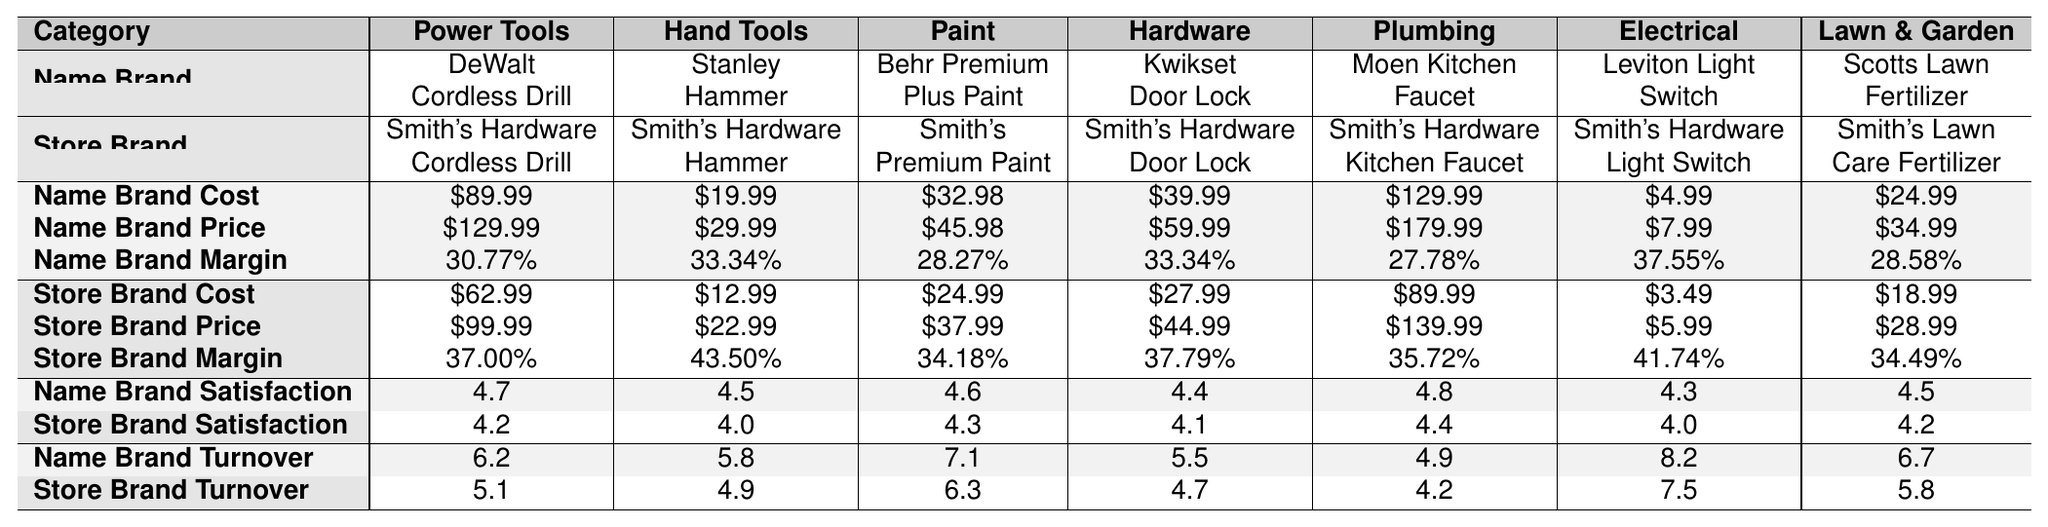What is the highest profit margin among the name-brand products? Look at the profit margin values for the name-brand products and identify the maximum. The values are 30.77%, 33.34%, 28.27%, 33.34%, 27.78%, 37.55%, and 28.58%. The highest is 37.55%.
Answer: 37.55% Which store-brand product has the lowest customer satisfaction rating? The ratings for store-brand products are 4.2, 4.0, 4.3, 4.1, 4.4, 4.0, and 4.2. The lowest rating is 4.0 for both the store-brand hammer and the light switch.
Answer: 4.0 What is the average profit margin for store-brand products? Sum the profit margins for store-brand products: 37.00% + 43.50% + 34.18% + 37.79% + 35.72% + 41.74% + 34.49% = 264.42%. Divide by the number of products (7): 264.42% / 7 = 37.77%.
Answer: 37.77% Are name-brand products generally associated with higher customer satisfaction than store-brand products? Comparing the average customer satisfaction ratings, name-brand products have an average of (4.7 + 4.5 + 4.6 + 4.4 + 4.8 + 4.3 + 4.5) / 7 = 4.57, while store-brand products average (4.2 + 4.0 + 4.3 + 4.1 + 4.4 + 4.0 + 4.2) / 7 = 4.19. Since 4.57 > 4.19, name-brand products have higher satisfaction.
Answer: Yes What is the difference in profit margins between the name-brand and store-brand paint products? The profit margins for name-brand paint is 28.27%, and for store-brand paint, it is 34.18%. Calculate the difference: 34.18% - 28.27% = 5.91%.
Answer: 5.91% Which product category shows the greatest difference in cost between name-brand and store-brand products? Calculate the cost difference for each category: Power Tools: 89.99 - 62.99 = 27.00, Hand Tools: 19.99 - 12.99 = 7.00, Paint: 32.98 - 24.99 = 7.99, Hardware: 39.99 - 27.99 = 12.00, Plumbing: 129.99 - 89.99 = 40.00, Electrical: 4.99 - 3.49 = 1.50, Lawn & Garden: 24.99 - 18.99 = 6.00. The greatest difference is 40.00 in the Plumbing category.
Answer: 40.00 What is the total inventory turnover for name-brand products? Sum the inventory turnover values for name-brand products: 6.2 + 5.8 + 7.1 + 5.5 + 4.9 + 8.2 + 6.7 = 44.4.
Answer: 44.4 Is the average selling price of store-brand products higher than that of name-brand products? Calculate the average selling price for each: Name-brand: (129.99 + 29.99 + 45.98 + 59.99 + 179.99 + 7.99 + 34.99) / 7 = 56.43, Store-brand: (99.99 + 22.99 + 37.99 + 44.99 + 139.99 + 5.99 + 28.99) / 7 = 52.14. Therefore, 56.43 > 52.14, so name-brand is higher.
Answer: No What product category has the highest average inventory turnover? Calculate the average inventory turnover for each category: Power Tools: 6.2, Hand Tools: 5.8, Paint: 7.1, Hardware: 5.5, Plumbing: 4.9, Electrical: 8.2, Lawn & Garden: 6.7. The highest is 8.2 for Electrical.
Answer: Electrical Which brand has a higher profit margin in the Lawn & Garden category? Compare the profit margins for Lawn & Garden: Name-brand (28.58%) vs. Store-brand (34.49%). 34.49% > 28.58%, so store-brand has a higher profit margin.
Answer: Store-brand 